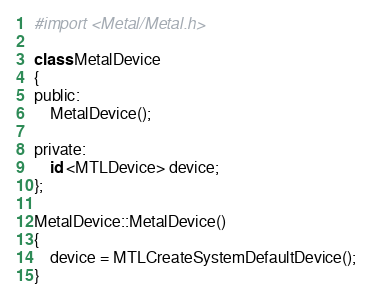Convert code to text. <code><loc_0><loc_0><loc_500><loc_500><_ObjectiveC_>#import <Metal/Metal.h>

class MetalDevice
{
public:
    MetalDevice();

private:
    id <MTLDevice> device;
};

MetalDevice::MetalDevice()
{
    device = MTLCreateSystemDefaultDevice();
}
</code> 